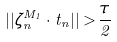Convert formula to latex. <formula><loc_0><loc_0><loc_500><loc_500>| | \zeta _ { n } ^ { M _ { 1 } } \cdot t _ { n } | | > \frac { \tau } { 2 }</formula> 